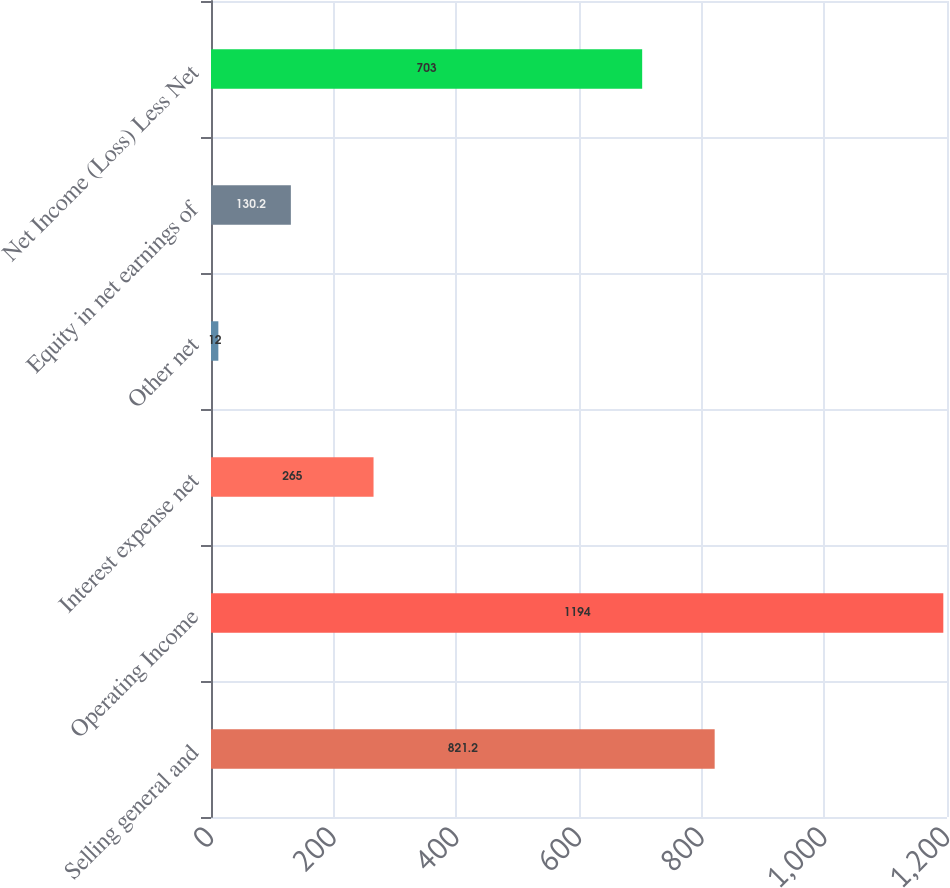Convert chart. <chart><loc_0><loc_0><loc_500><loc_500><bar_chart><fcel>Selling general and<fcel>Operating Income<fcel>Interest expense net<fcel>Other net<fcel>Equity in net earnings of<fcel>Net Income (Loss) Less Net<nl><fcel>821.2<fcel>1194<fcel>265<fcel>12<fcel>130.2<fcel>703<nl></chart> 